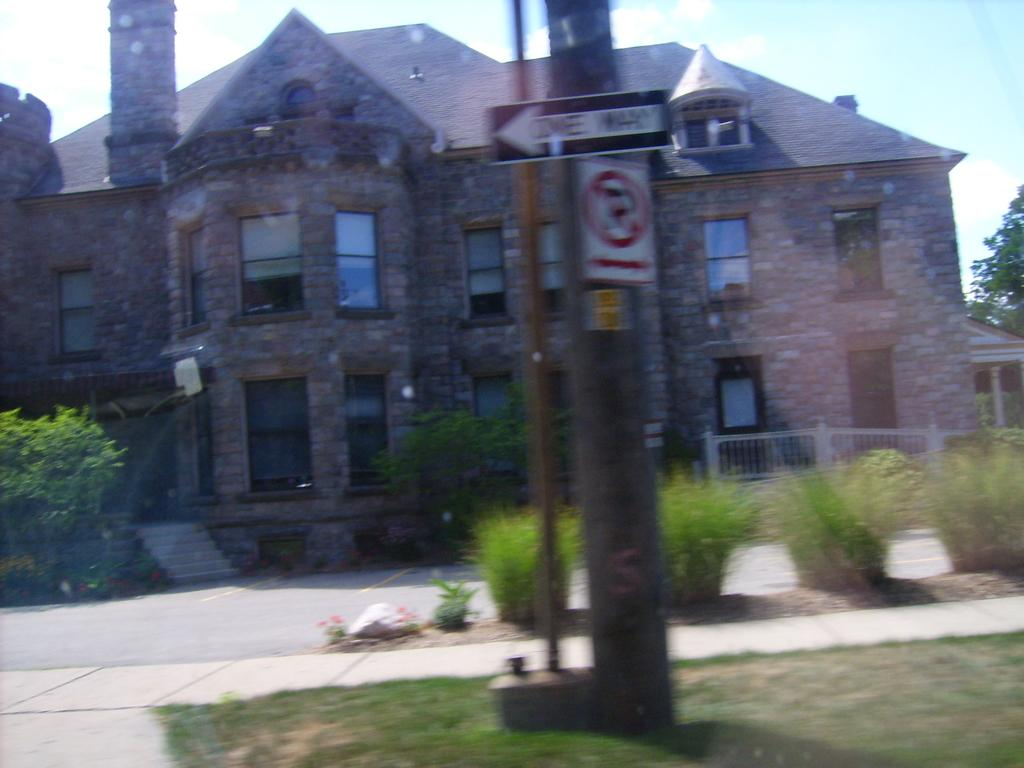What type of structure is present in the image? There is a house in the image. What can be seen besides the house? There is a road, grass, poles, boards, plants, and branches visible in the image. What is the natural environment like in the image? The natural environment includes grass, plants, and branches. What is visible in the background of the image? The sky is visible in the background of the image, with clouds present. What type of drug is being sold at the house in the image? There is no indication of any drug being sold or present in the image. The image only shows a house, a road, grass, poles, boards, plants, branches, and the sky with clouds. 